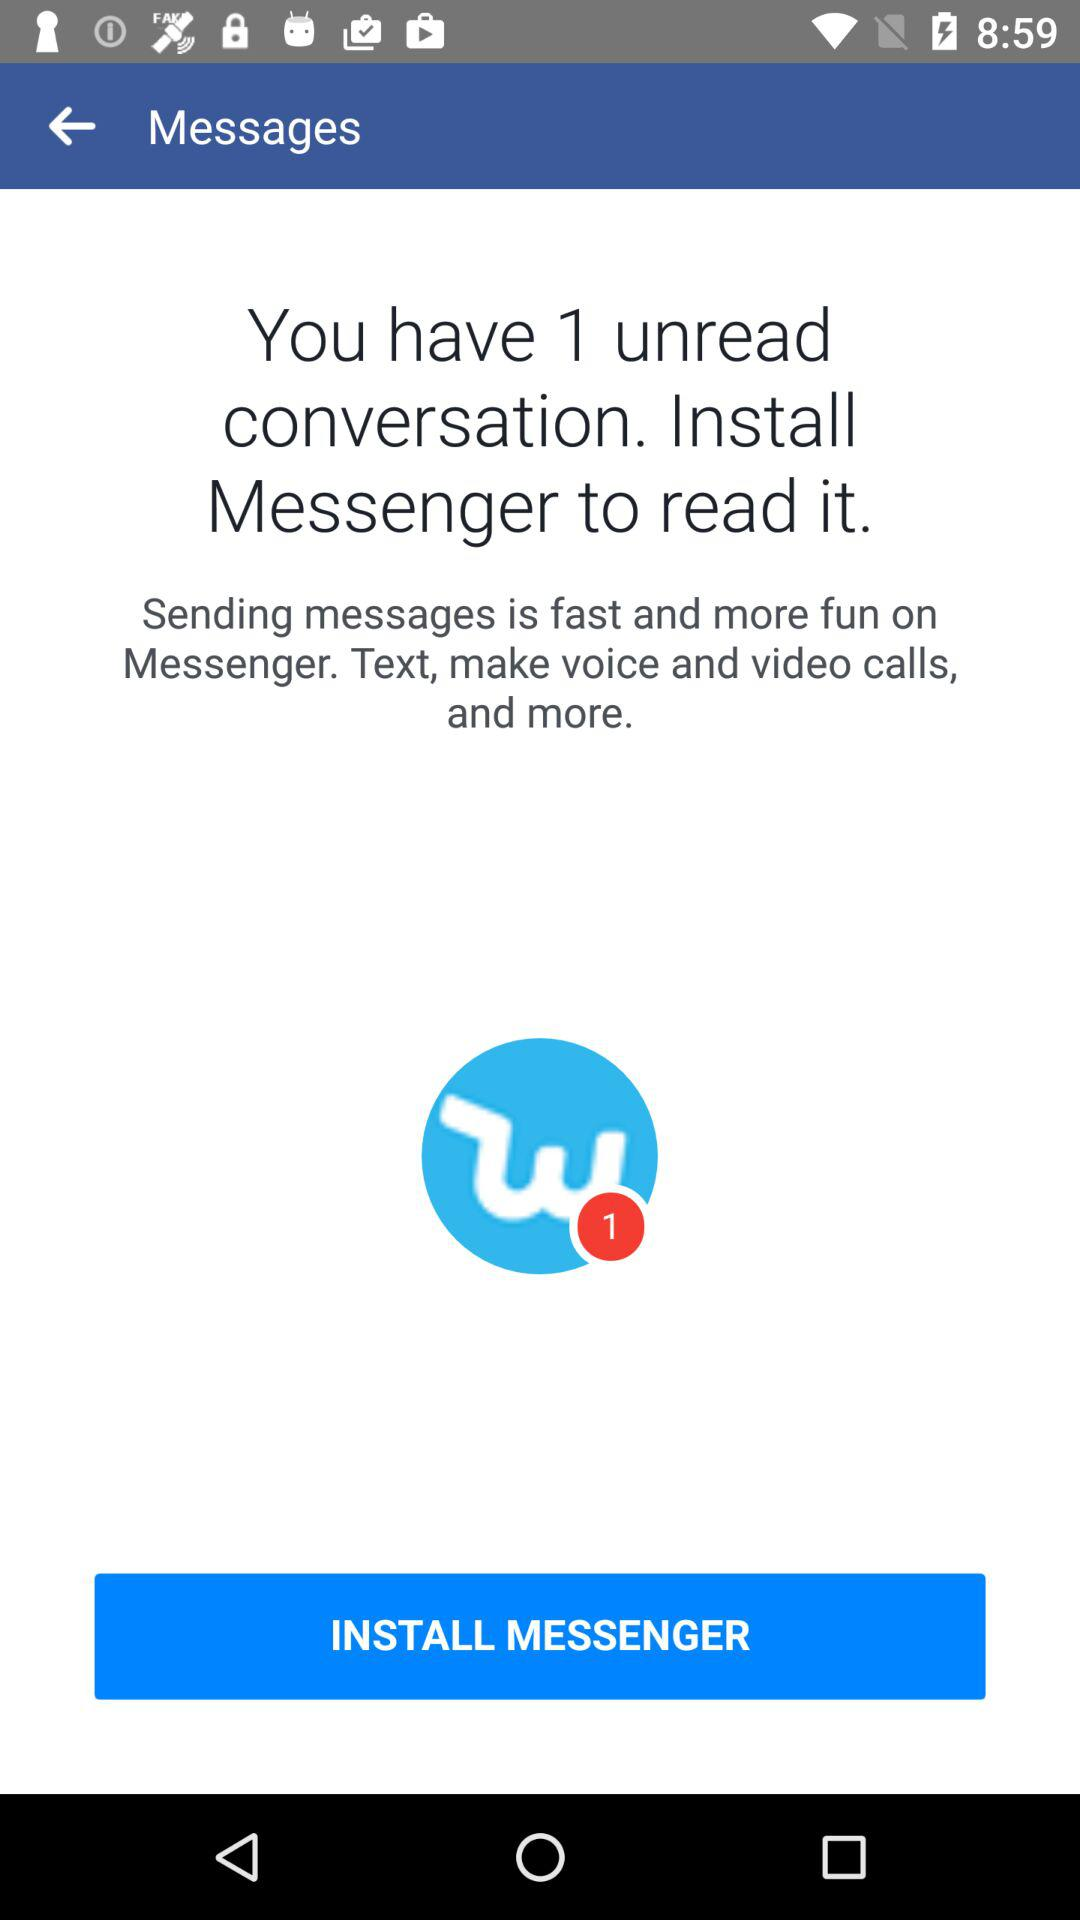Are there any unread conversations? There is 1 unread conversation. 